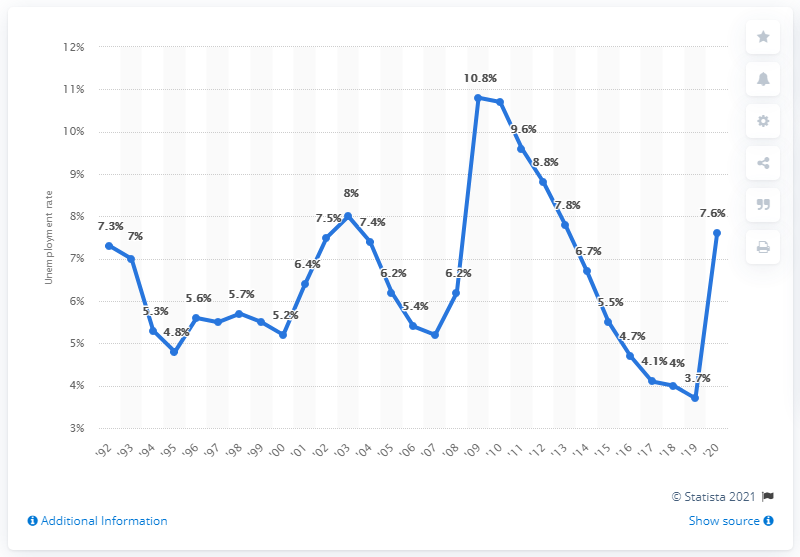Specify some key components in this picture. In 2009, the unemployment rate in Oregon was 3.7%. In 2009, the highest unemployment rate in Oregon was 10.7%. 